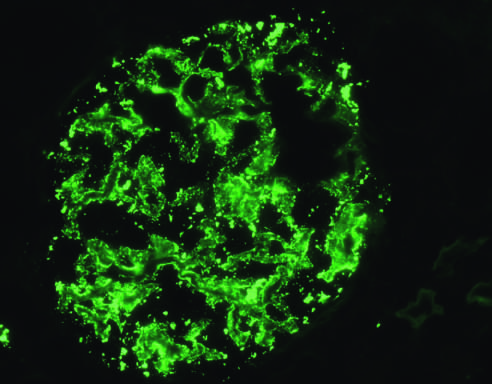what is detected by immunofluorescence?
Answer the question using a single word or phrase. Deposition of igg antibody 